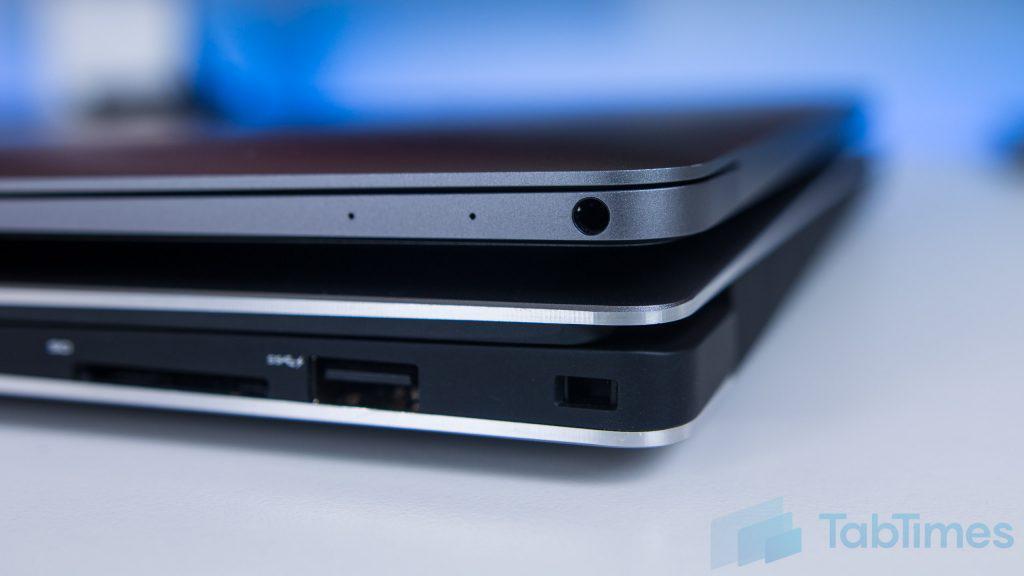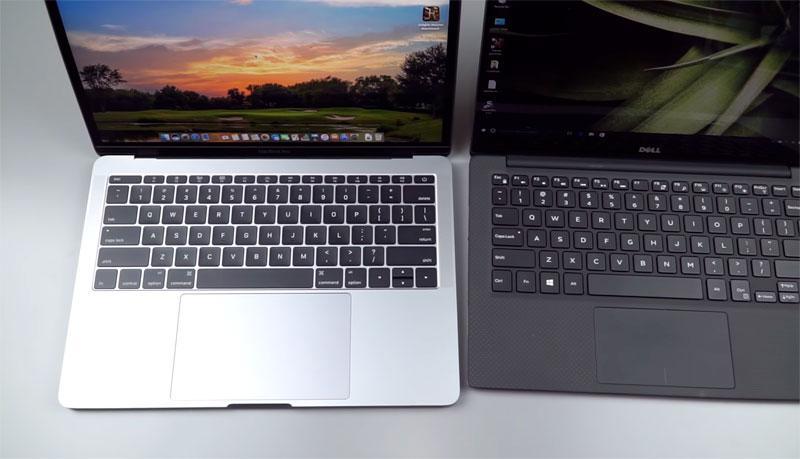The first image is the image on the left, the second image is the image on the right. Given the left and right images, does the statement "The left image features one closed laptop stacked on another, and the right image shows side-by-side open laptops." hold true? Answer yes or no. Yes. The first image is the image on the left, the second image is the image on the right. Assess this claim about the two images: "In the image on the right 2 laptops are placed side by side.". Correct or not? Answer yes or no. Yes. 